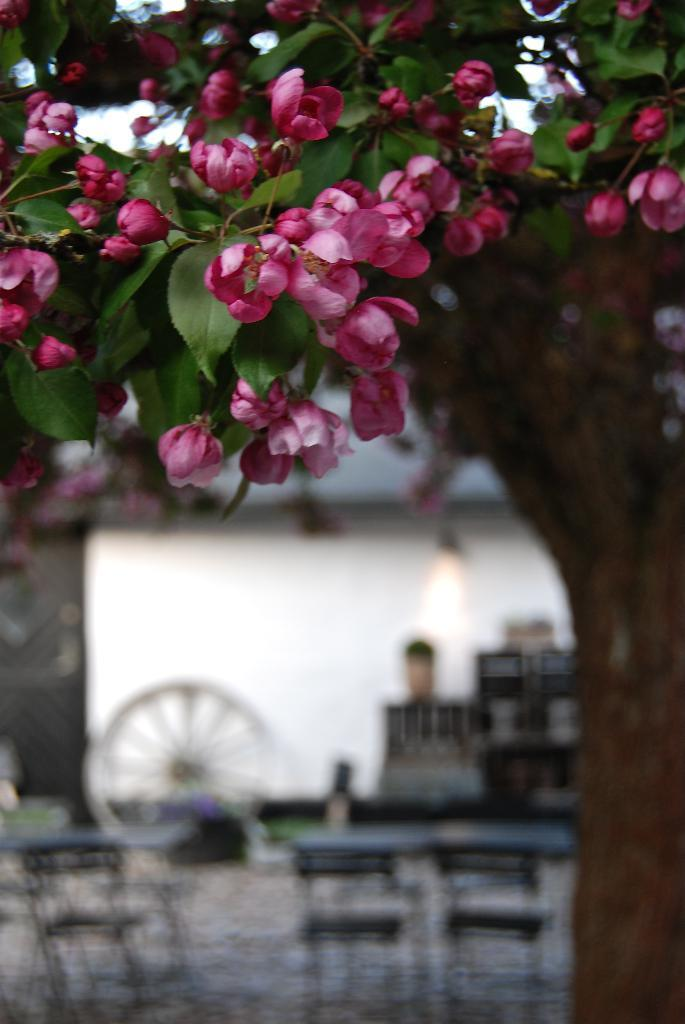What is present in the picture? There is a tree in the picture. Can you describe the tree? The tree has leaves and pink color flowers. What can be seen in the backdrop of the picture? There are tables, chairs, and a wall in the backdrop of the picture. Who is the servant in the picture? There is no servant present in the picture. What type of cake is being served on the tables in the picture? There is no cake visible in the picture. 